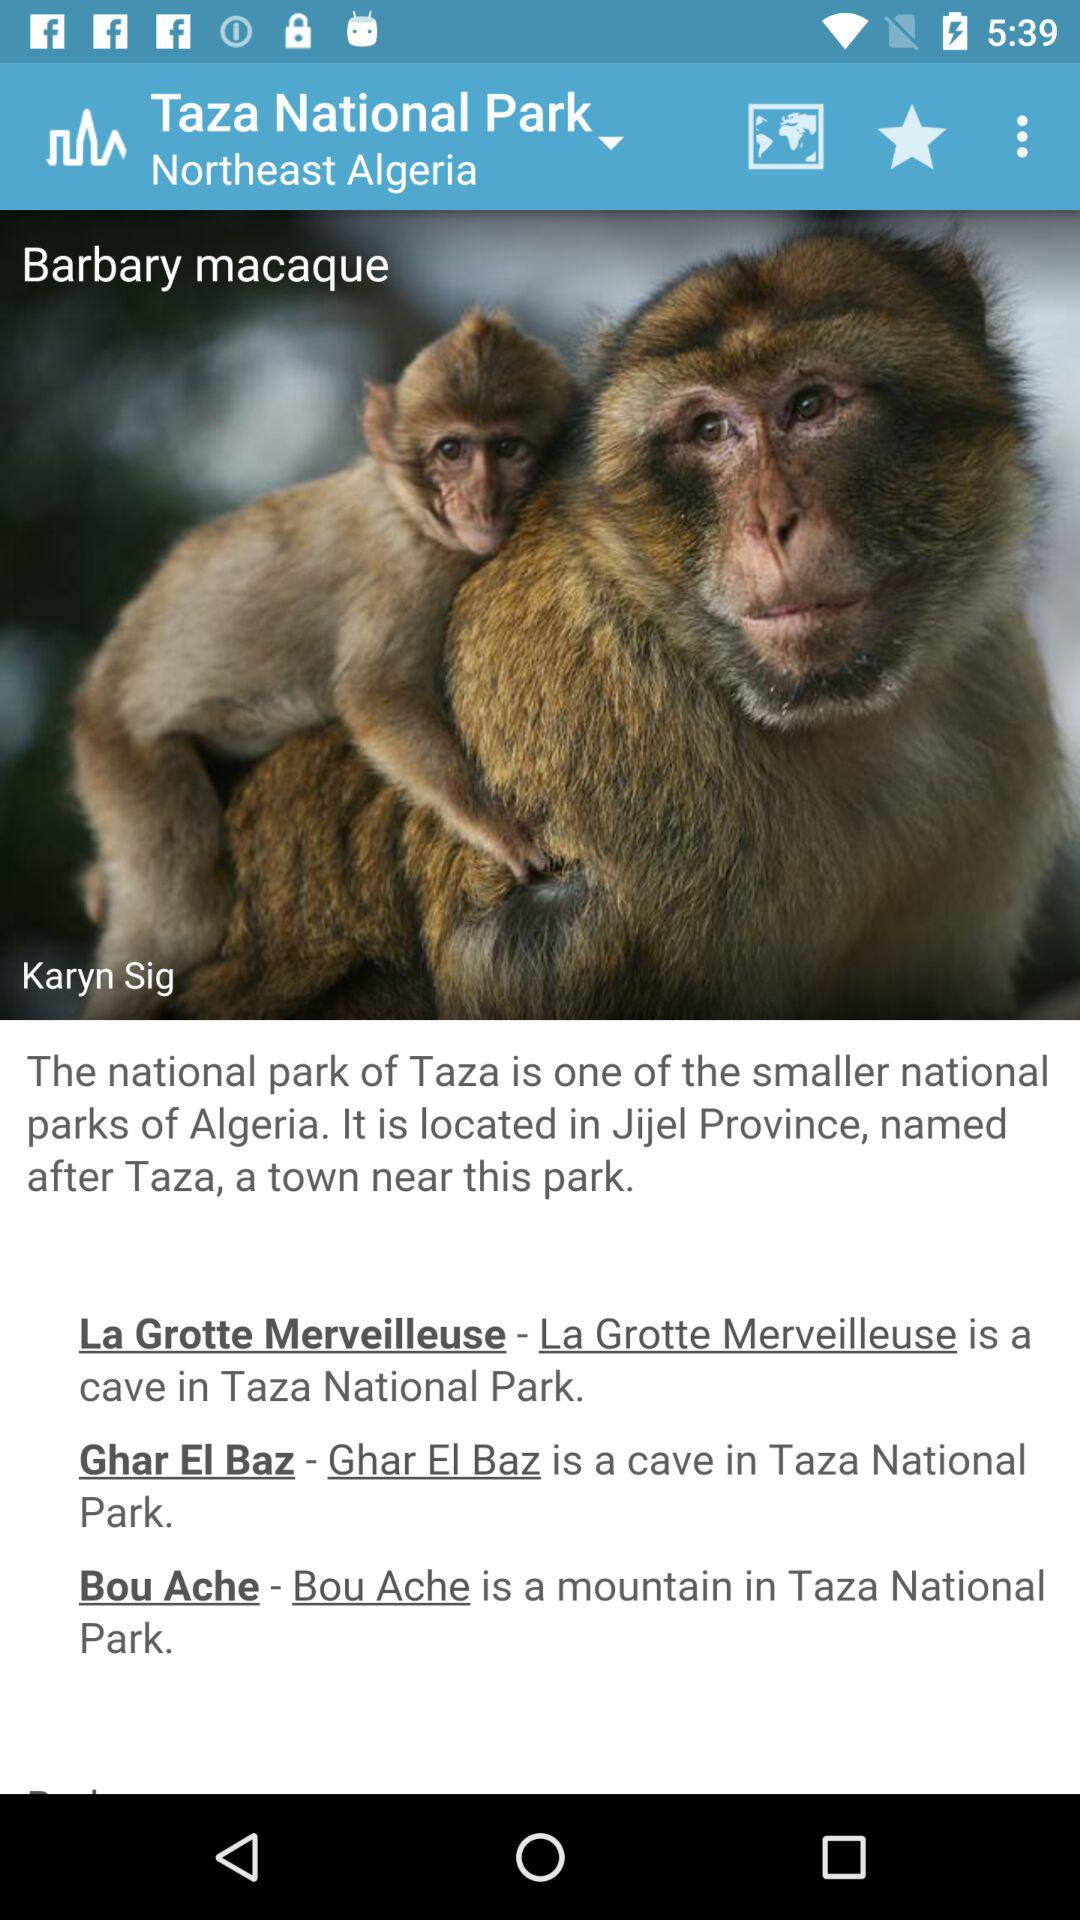What is the name of the national park? The name of the national park is "Taza National Park". 